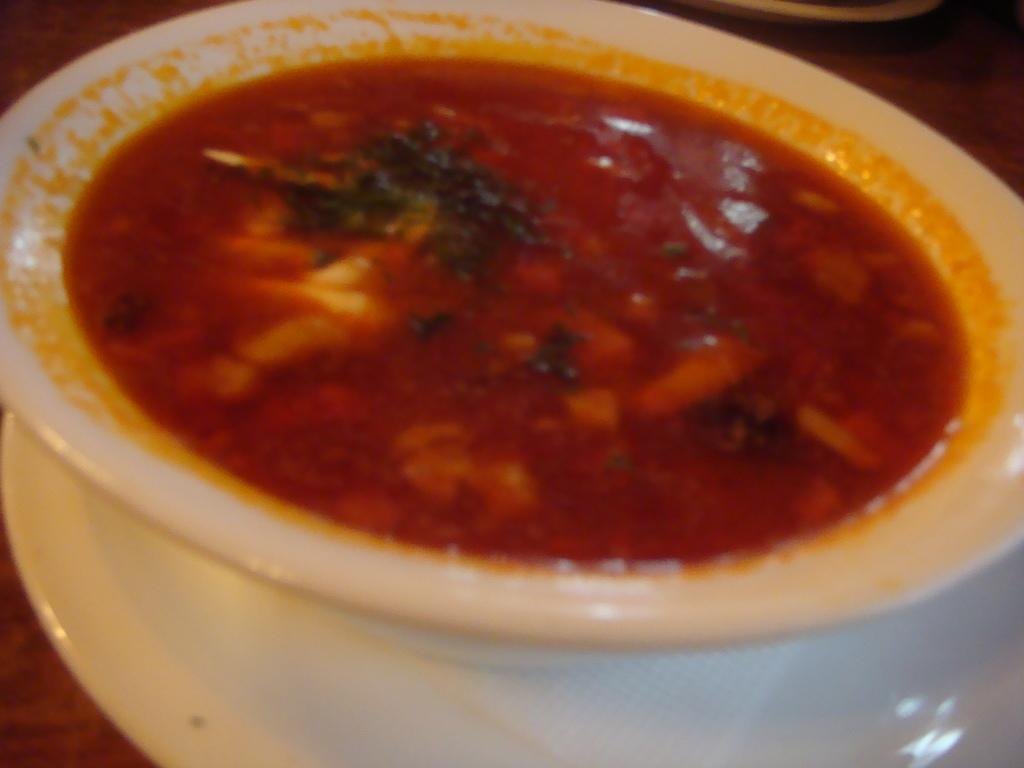What is in the bowl that is visible in the image? The bowl contains a food item. Where is the bowl located in the image? The bowl is placed on a table. Can you describe the food item in the bowl? Unfortunately, the specific food item cannot be determined from the provided facts. What type of collar is visible on the box in the image? There is no box or collar present in the image. 